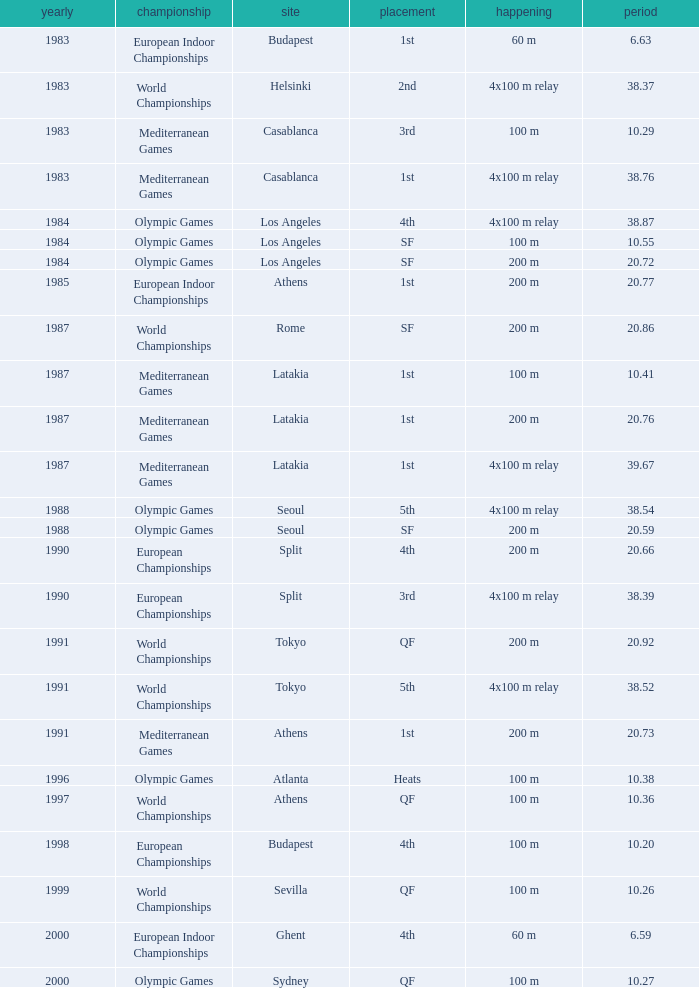What Position has a Time of 20.66? 4th. Parse the full table. {'header': ['yearly', 'championship', 'site', 'placement', 'happening', 'period'], 'rows': [['1983', 'European Indoor Championships', 'Budapest', '1st', '60 m', '6.63'], ['1983', 'World Championships', 'Helsinki', '2nd', '4x100 m relay', '38.37'], ['1983', 'Mediterranean Games', 'Casablanca', '3rd', '100 m', '10.29'], ['1983', 'Mediterranean Games', 'Casablanca', '1st', '4x100 m relay', '38.76'], ['1984', 'Olympic Games', 'Los Angeles', '4th', '4x100 m relay', '38.87'], ['1984', 'Olympic Games', 'Los Angeles', 'SF', '100 m', '10.55'], ['1984', 'Olympic Games', 'Los Angeles', 'SF', '200 m', '20.72'], ['1985', 'European Indoor Championships', 'Athens', '1st', '200 m', '20.77'], ['1987', 'World Championships', 'Rome', 'SF', '200 m', '20.86'], ['1987', 'Mediterranean Games', 'Latakia', '1st', '100 m', '10.41'], ['1987', 'Mediterranean Games', 'Latakia', '1st', '200 m', '20.76'], ['1987', 'Mediterranean Games', 'Latakia', '1st', '4x100 m relay', '39.67'], ['1988', 'Olympic Games', 'Seoul', '5th', '4x100 m relay', '38.54'], ['1988', 'Olympic Games', 'Seoul', 'SF', '200 m', '20.59'], ['1990', 'European Championships', 'Split', '4th', '200 m', '20.66'], ['1990', 'European Championships', 'Split', '3rd', '4x100 m relay', '38.39'], ['1991', 'World Championships', 'Tokyo', 'QF', '200 m', '20.92'], ['1991', 'World Championships', 'Tokyo', '5th', '4x100 m relay', '38.52'], ['1991', 'Mediterranean Games', 'Athens', '1st', '200 m', '20.73'], ['1996', 'Olympic Games', 'Atlanta', 'Heats', '100 m', '10.38'], ['1997', 'World Championships', 'Athens', 'QF', '100 m', '10.36'], ['1998', 'European Championships', 'Budapest', '4th', '100 m', '10.20'], ['1999', 'World Championships', 'Sevilla', 'QF', '100 m', '10.26'], ['2000', 'European Indoor Championships', 'Ghent', '4th', '60 m', '6.59'], ['2000', 'Olympic Games', 'Sydney', 'QF', '100 m', '10.27']]} 